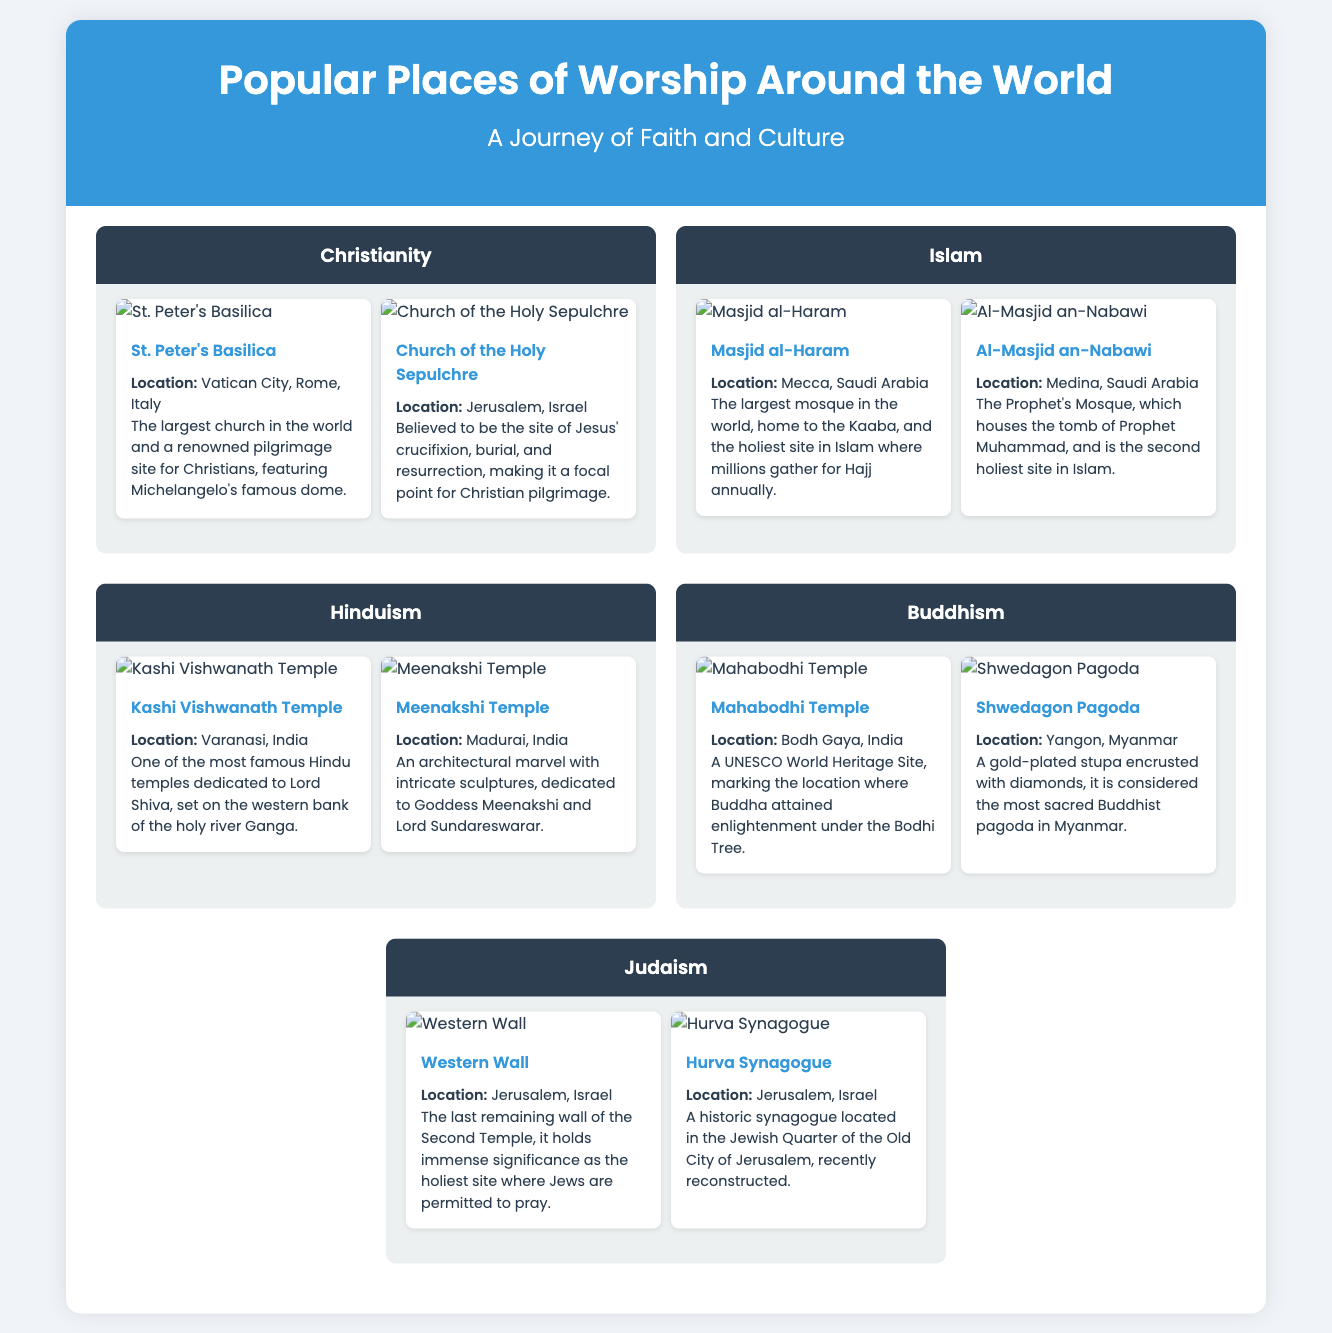what is the largest church in the world? The document states that St. Peter's Basilica is the largest church in the world.
Answer: St. Peter's Basilica where is the Masjid al-Haram located? According to the document, the Masjid al-Haram is located in Mecca, Saudi Arabia.
Answer: Mecca, Saudi Arabia how many places of worship are listed under Buddhism? The document lists two places of worship under Buddhism: Mahabodhi Temple and Shwedagon Pagoda.
Answer: Two what is the significance of the Western Wall? The document explains that the Western Wall is the holiest site where Jews are permitted to pray.
Answer: Holiest site for prayer which religion's temple is Kashi Vishwanath Temple dedicated to? The document indicates that Kashi Vishwanath Temple is dedicated to Hinduism.
Answer: Hinduism what city hosts the Hurva Synagogue? The document specifies that the Hurva Synagogue is located in Jerusalem, Israel.
Answer: Jerusalem, Israel which place is known for being the site of Buddha’s enlightenment? The document states that the Mahabodhi Temple marks the location where Buddha attained enlightenment.
Answer: Mahabodhi Temple how many religious traditions are represented in the infographic? The document shows that there are five religious traditions represented: Christianity, Islam, Hinduism, Buddhism, and Judaism.
Answer: Five 